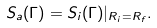Convert formula to latex. <formula><loc_0><loc_0><loc_500><loc_500>S _ { a } ( \Gamma ) = S _ { i } ( \Gamma ) | _ { R _ { i } = R _ { f } } .</formula> 